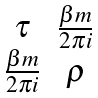Convert formula to latex. <formula><loc_0><loc_0><loc_500><loc_500>\begin{matrix} \tau & \frac { \beta m } { 2 \pi i } \\ \frac { \beta m } { 2 \pi i } & \rho \end{matrix}</formula> 